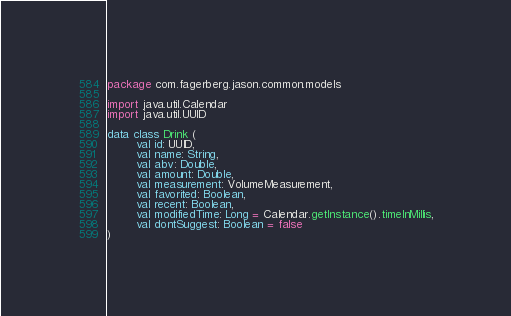<code> <loc_0><loc_0><loc_500><loc_500><_Kotlin_>package com.fagerberg.jason.common.models

import java.util.Calendar
import java.util.UUID

data class Drink (
        val id: UUID,
        val name: String,
        val abv: Double,
        val amount: Double,
        val measurement: VolumeMeasurement,
        val favorited: Boolean,
        val recent: Boolean,
        val modifiedTime: Long = Calendar.getInstance().timeInMillis,
        val dontSuggest: Boolean = false
)
</code> 